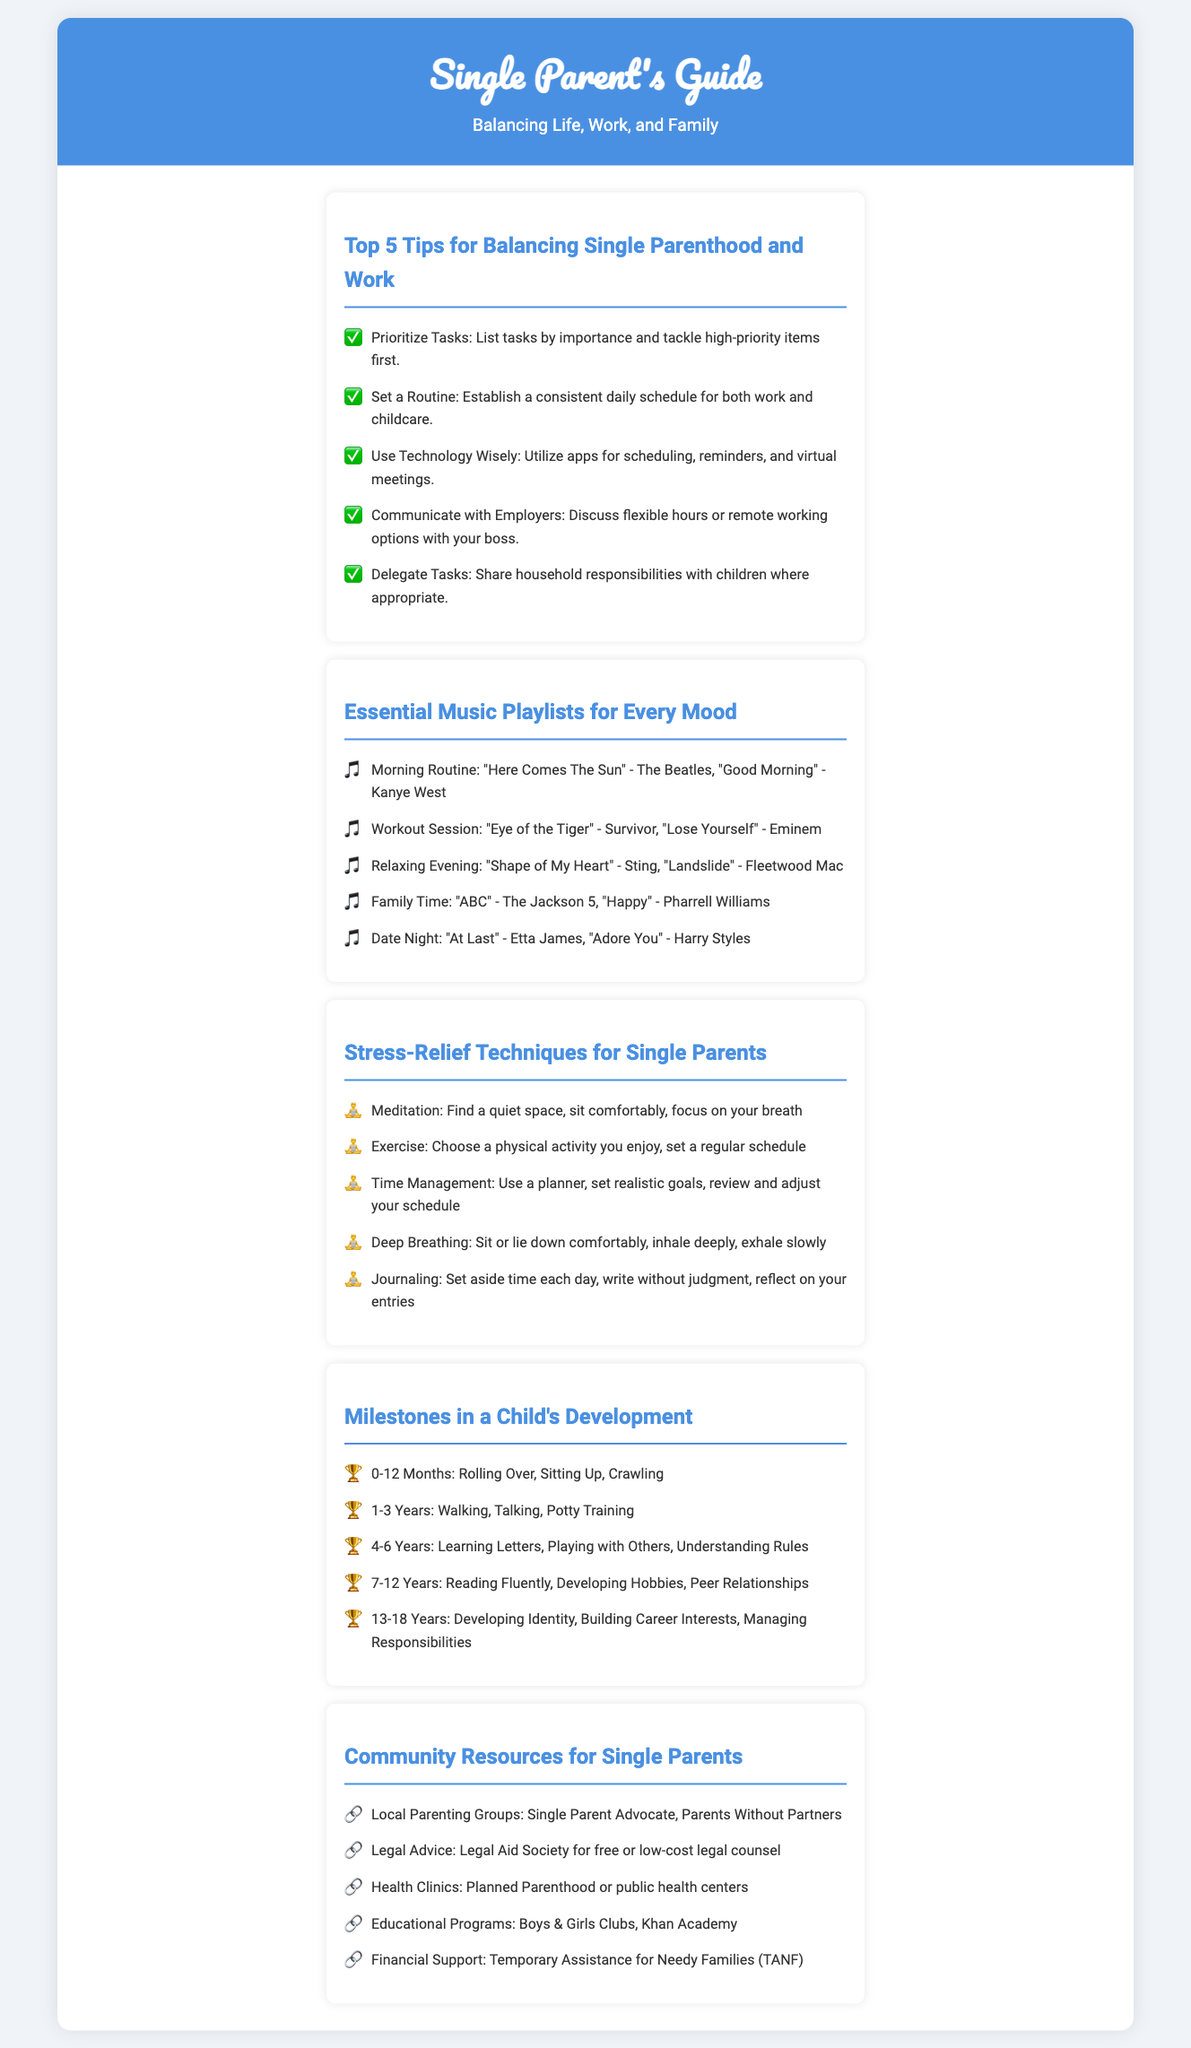What are the top tips for balancing single parenthood and work? The document lists five tips including prioritizing tasks and setting a routine.
Answer: Prioritize Tasks, Set a Routine, Use Technology Wisely, Communicate with Employers, Delegate Tasks Which playlist is recommended for a morning routine? The document provides a list of songs for morning routines.
Answer: "Here Comes The Sun" - The Beatles, "Good Morning" - Kanye West What is one technique for stress relief mentioned? The document highlights several stress-relief techniques including meditation and exercise.
Answer: Meditation At what age does a child typically start walking? The milestones section indicates when children achieve walking skills.
Answer: 1-3 Years What community resource is available for legal advice? The document lists resources including local organizations providing legal help.
Answer: Legal Aid Society How many songs are suggested for a workout session? The document mentions two songs specifically curated for workout sessions.
Answer: 2 Which developmental milestone occurs between ages 7-12? The document lists milestones related to age ranges.
Answer: Reading Fluently What methods for time management does the stress-relief section suggest? The document specifies using a planner and setting realistic goals for time management.
Answer: Use a planner, set realistic goals What is the contact icon for community resources? The document illustrates community resources with specific icons.
Answer: 🔗 